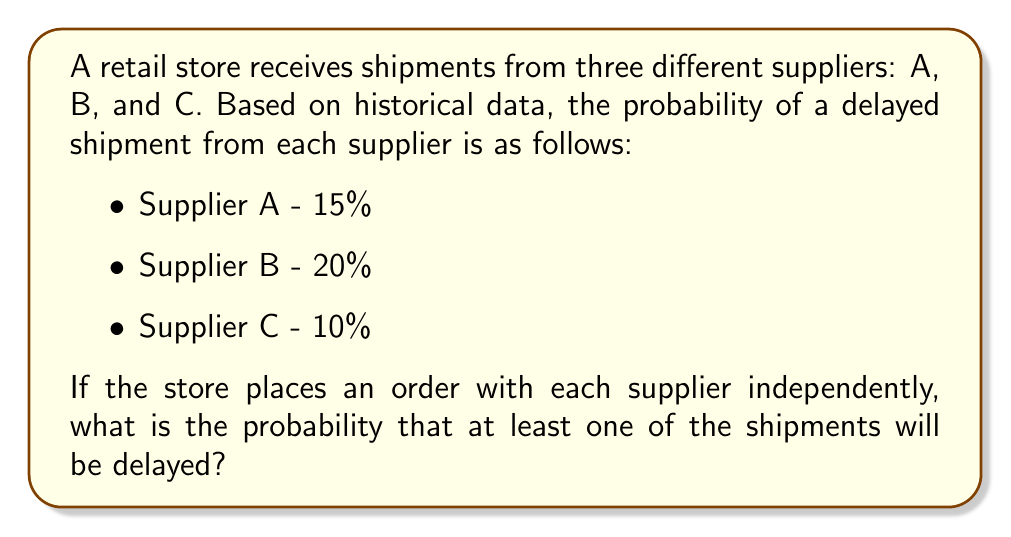Solve this math problem. Let's approach this step-by-step:

1) First, we need to find the probability that all shipments arrive on time. This is easier than directly calculating the probability of at least one delay.

2) For each supplier, the probability of an on-time shipment is:
   Supplier A: $1 - 0.15 = 0.85$
   Supplier B: $1 - 0.20 = 0.80$
   Supplier C: $1 - 0.10 = 0.90$

3) Since the orders are placed independently, we can multiply these probabilities:

   $P(\text{all on time}) = 0.85 \times 0.80 \times 0.90 = 0.612$

4) Now, the probability of at least one delay is the complement of all shipments being on time:

   $P(\text{at least one delay}) = 1 - P(\text{all on time})$

5) Therefore:

   $P(\text{at least one delay}) = 1 - 0.612 = 0.388$

6) Converting to a percentage:

   $0.388 \times 100\% = 38.8\%$
Answer: 38.8% 